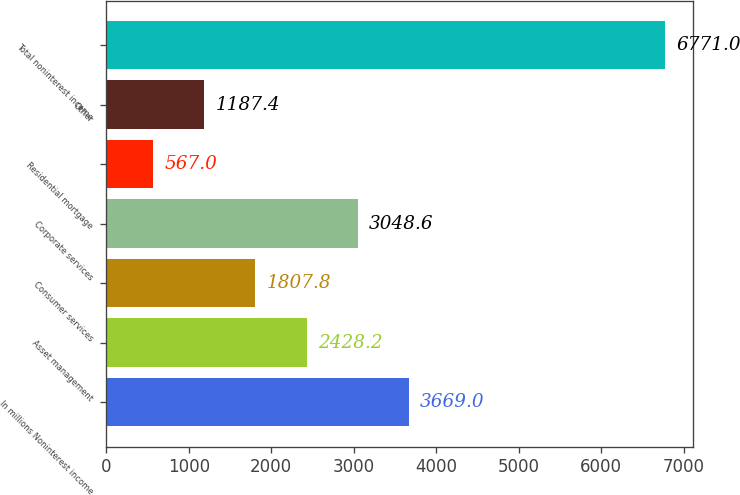Convert chart. <chart><loc_0><loc_0><loc_500><loc_500><bar_chart><fcel>In millions Noninterest income<fcel>Asset management<fcel>Consumer services<fcel>Corporate services<fcel>Residential mortgage<fcel>Other<fcel>Total noninterest income<nl><fcel>3669<fcel>2428.2<fcel>1807.8<fcel>3048.6<fcel>567<fcel>1187.4<fcel>6771<nl></chart> 